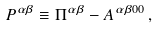Convert formula to latex. <formula><loc_0><loc_0><loc_500><loc_500>P ^ { \alpha \beta } \equiv \Pi ^ { \alpha \beta } - A ^ { \alpha \beta 0 0 } \, ,</formula> 